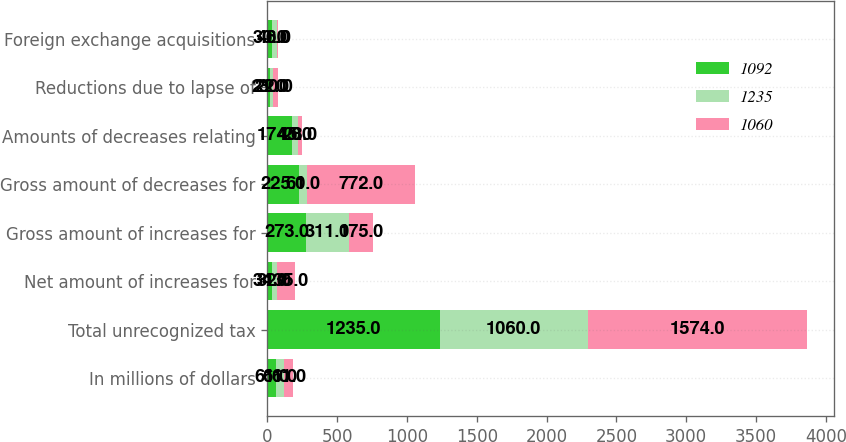Convert chart. <chart><loc_0><loc_0><loc_500><loc_500><stacked_bar_chart><ecel><fcel>In millions of dollars<fcel>Total unrecognized tax<fcel>Net amount of increases for<fcel>Gross amount of increases for<fcel>Gross amount of decreases for<fcel>Amounts of decreases relating<fcel>Reductions due to lapse of<fcel>Foreign exchange acquisitions<nl><fcel>1092<fcel>61<fcel>1235<fcel>34<fcel>273<fcel>225<fcel>174<fcel>21<fcel>30<nl><fcel>1235<fcel>61<fcel>1060<fcel>32<fcel>311<fcel>61<fcel>45<fcel>22<fcel>40<nl><fcel>1060<fcel>61<fcel>1574<fcel>135<fcel>175<fcel>772<fcel>28<fcel>30<fcel>6<nl></chart> 